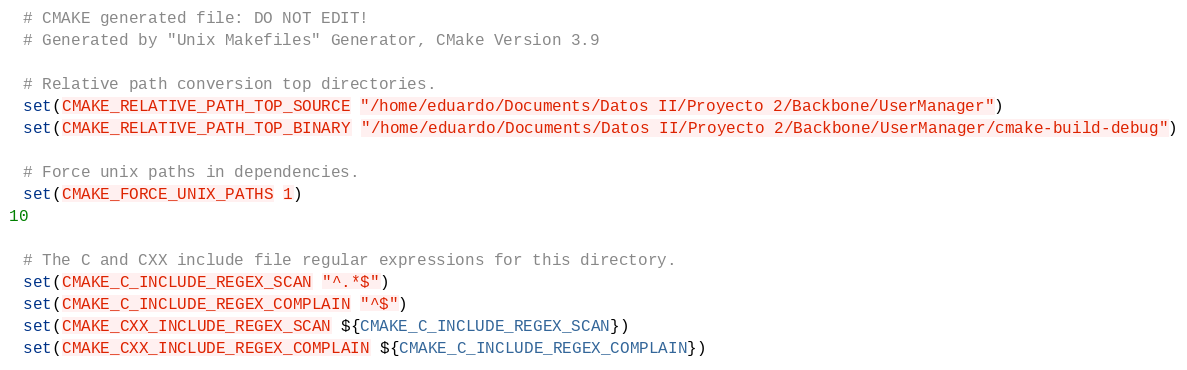<code> <loc_0><loc_0><loc_500><loc_500><_CMake_># CMAKE generated file: DO NOT EDIT!
# Generated by "Unix Makefiles" Generator, CMake Version 3.9

# Relative path conversion top directories.
set(CMAKE_RELATIVE_PATH_TOP_SOURCE "/home/eduardo/Documents/Datos II/Proyecto 2/Backbone/UserManager")
set(CMAKE_RELATIVE_PATH_TOP_BINARY "/home/eduardo/Documents/Datos II/Proyecto 2/Backbone/UserManager/cmake-build-debug")

# Force unix paths in dependencies.
set(CMAKE_FORCE_UNIX_PATHS 1)


# The C and CXX include file regular expressions for this directory.
set(CMAKE_C_INCLUDE_REGEX_SCAN "^.*$")
set(CMAKE_C_INCLUDE_REGEX_COMPLAIN "^$")
set(CMAKE_CXX_INCLUDE_REGEX_SCAN ${CMAKE_C_INCLUDE_REGEX_SCAN})
set(CMAKE_CXX_INCLUDE_REGEX_COMPLAIN ${CMAKE_C_INCLUDE_REGEX_COMPLAIN})
</code> 